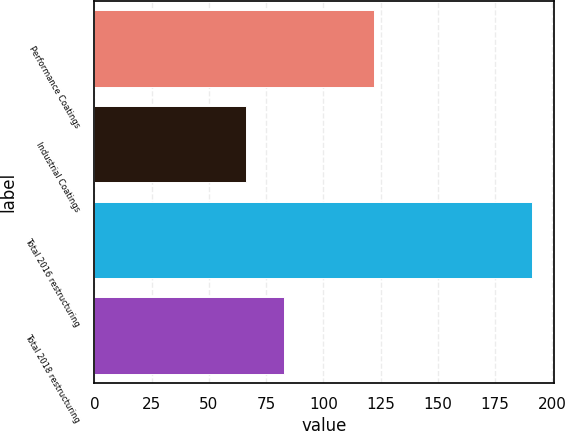Convert chart to OTSL. <chart><loc_0><loc_0><loc_500><loc_500><bar_chart><fcel>Performance Coatings<fcel>Industrial Coatings<fcel>Total 2016 restructuring<fcel>Total 2018 restructuring<nl><fcel>122<fcel>66<fcel>191<fcel>83<nl></chart> 